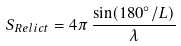<formula> <loc_0><loc_0><loc_500><loc_500>S _ { R e l i c t } = 4 \pi \, \frac { \sin ( 1 8 0 ^ { \circ } / L ) } { \lambda }</formula> 